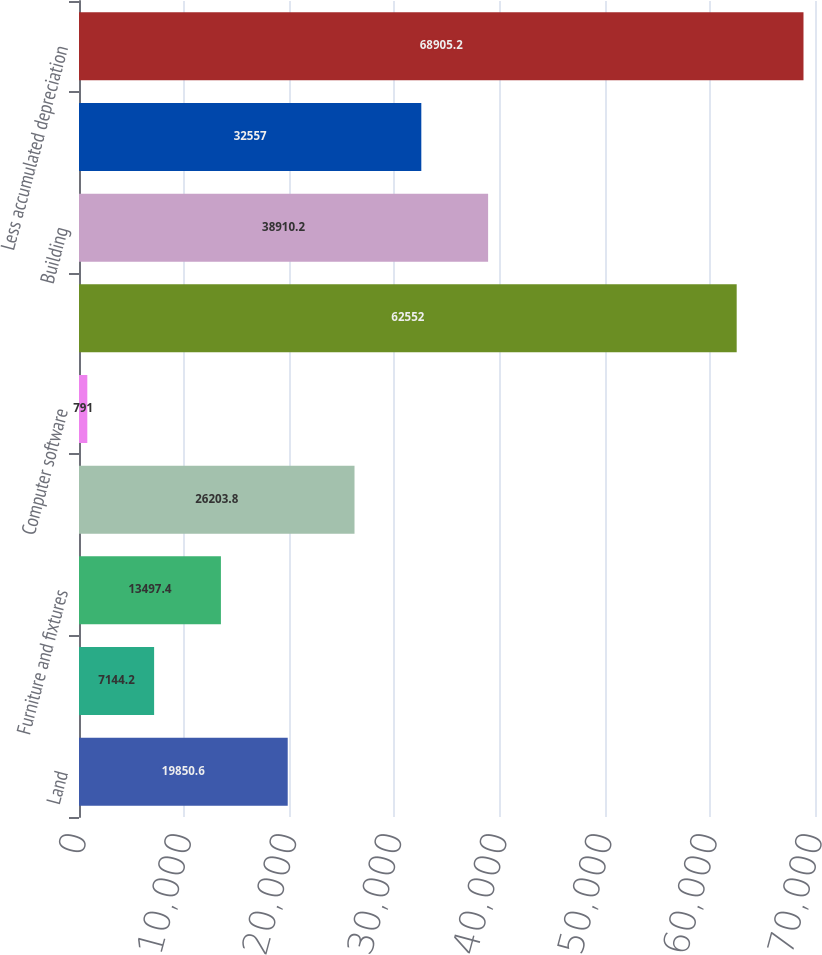Convert chart to OTSL. <chart><loc_0><loc_0><loc_500><loc_500><bar_chart><fcel>Land<fcel>Leasehold improvements<fcel>Furniture and fixtures<fcel>Office and computer equipment<fcel>Computer software<fcel>Equipment<fcel>Building<fcel>Vehicles<fcel>Less accumulated depreciation<nl><fcel>19850.6<fcel>7144.2<fcel>13497.4<fcel>26203.8<fcel>791<fcel>62552<fcel>38910.2<fcel>32557<fcel>68905.2<nl></chart> 